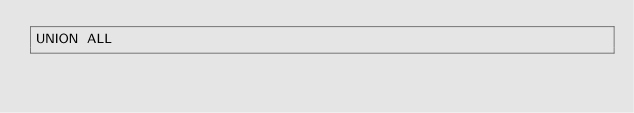Convert code to text. <code><loc_0><loc_0><loc_500><loc_500><_SQL_>UNION ALL
</code> 